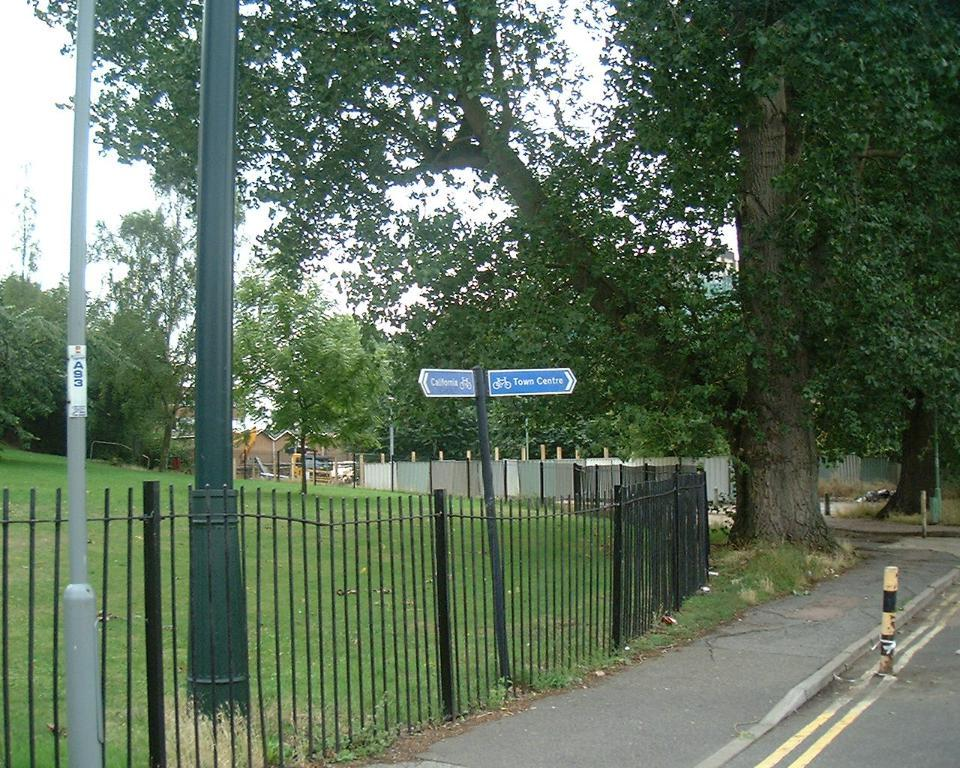What can be seen in the image that might be used for support or safety? There is a railing in the image that could be used for support or safety. What objects are attached to a pole in the image? There are two blue color boards attached to a pole in the image. What type of vegetation is present in the image? There are trees with green color in the image. What type of structure can be seen in the image? There is a building in the image. What color is the sky in the image? The sky is blue in the image. Reasoning: Let' Let's think step by step in order to produce the conversation. We start by identifying the main subjects and objects in the image based on the provided facts. We then formulate questions that focus on the characteristics and locations of these subjects and objects, ensuring that each question can be answered definitively with the information given. We avoid yes/no questions and ensure that the language is simple and clear. Absurd Question/Answer: What type of skirt is the grandmother wearing in the image? There is no grandmother or skirt present in the image. What type of cloud can be seen in the image? There are no clouds visible in the image; the sky is blue. 